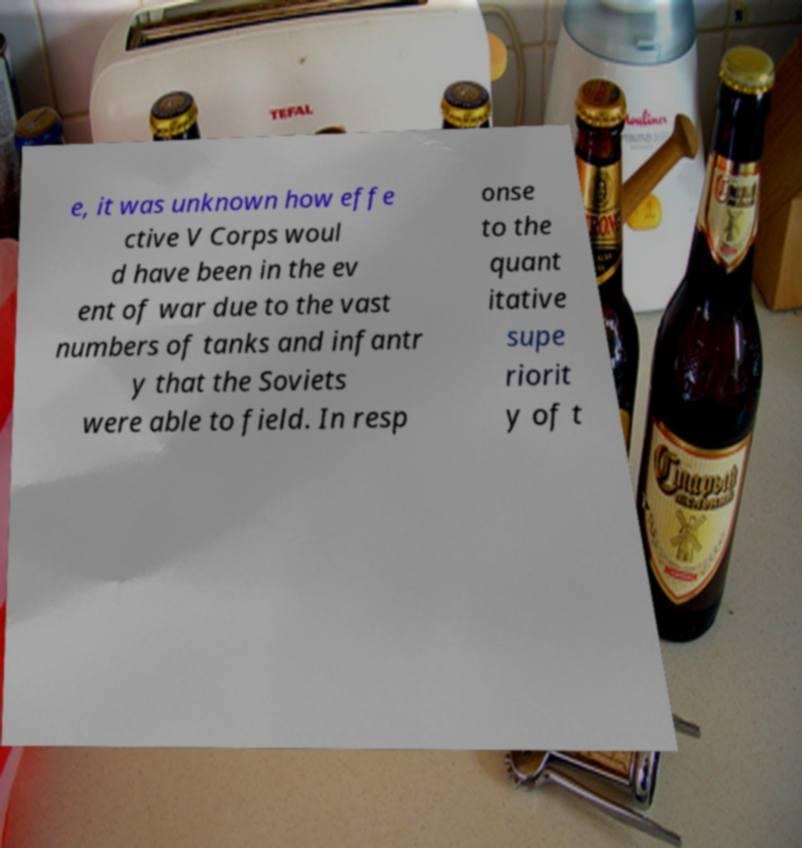What messages or text are displayed in this image? I need them in a readable, typed format. e, it was unknown how effe ctive V Corps woul d have been in the ev ent of war due to the vast numbers of tanks and infantr y that the Soviets were able to field. In resp onse to the quant itative supe riorit y of t 